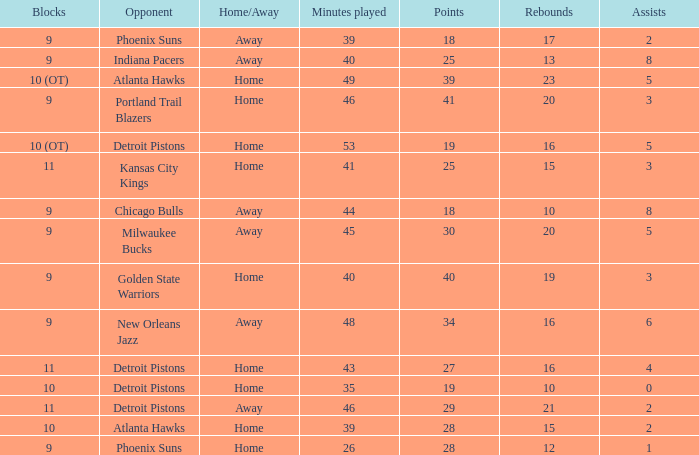How many points were scored when there were under 16 rebounds and 5 assists? 0.0. 